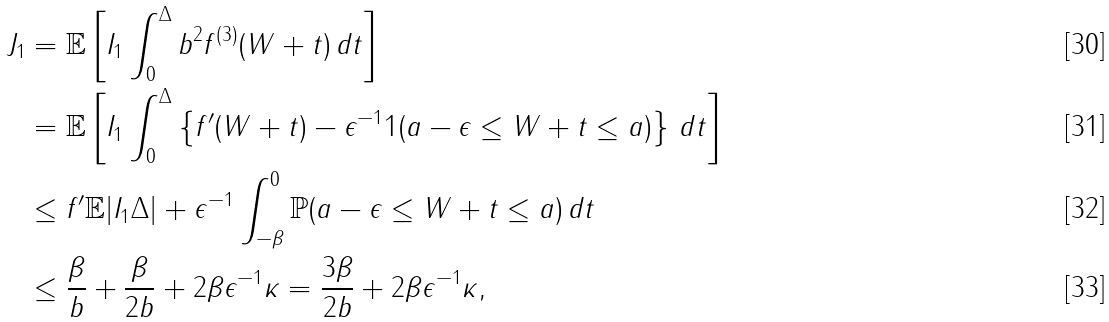Convert formula to latex. <formula><loc_0><loc_0><loc_500><loc_500>J _ { 1 } & = \mathbb { E } \left [ I _ { 1 } \int _ { 0 } ^ { \Delta } b ^ { 2 } f ^ { ( 3 ) } ( W + t ) \, d t \right ] \\ & = \mathbb { E } \left [ I _ { 1 } \int _ { 0 } ^ { \Delta } \left \{ f ^ { \prime } ( W + t ) - \epsilon ^ { - 1 } 1 ( a - \epsilon \leq W + t \leq a ) \right \} \, d t \right ] \\ & \leq \| f ^ { \prime } \| \mathbb { E } | I _ { 1 } \Delta | + \epsilon ^ { - 1 } \int _ { - \beta } ^ { 0 } \mathbb { P } ( a - \epsilon \leq W + t \leq a ) \, d t \\ & \leq \frac { \beta } { b } + \frac { \beta } { 2 b } + 2 \beta \epsilon ^ { - 1 } \kappa = \frac { 3 \beta } { 2 b } + 2 \beta \epsilon ^ { - 1 } \kappa ,</formula> 